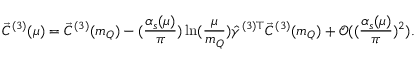Convert formula to latex. <formula><loc_0><loc_0><loc_500><loc_500>\vec { C } ^ { ( 3 ) } ( \mu ) = \vec { C } ^ { ( 3 ) } ( m _ { Q } ) - ( \frac { \alpha _ { s } ( \mu ) } { \pi } ) \ln ( \frac { \mu } { m _ { Q } } ) \hat { \gamma } ^ { ( 3 ) \top } \vec { C } ^ { ( 3 ) } ( m _ { Q } ) + \mathcal { O } ( ( \frac { \alpha _ { s } ( \mu ) } { \pi } ) ^ { 2 } ) .</formula> 